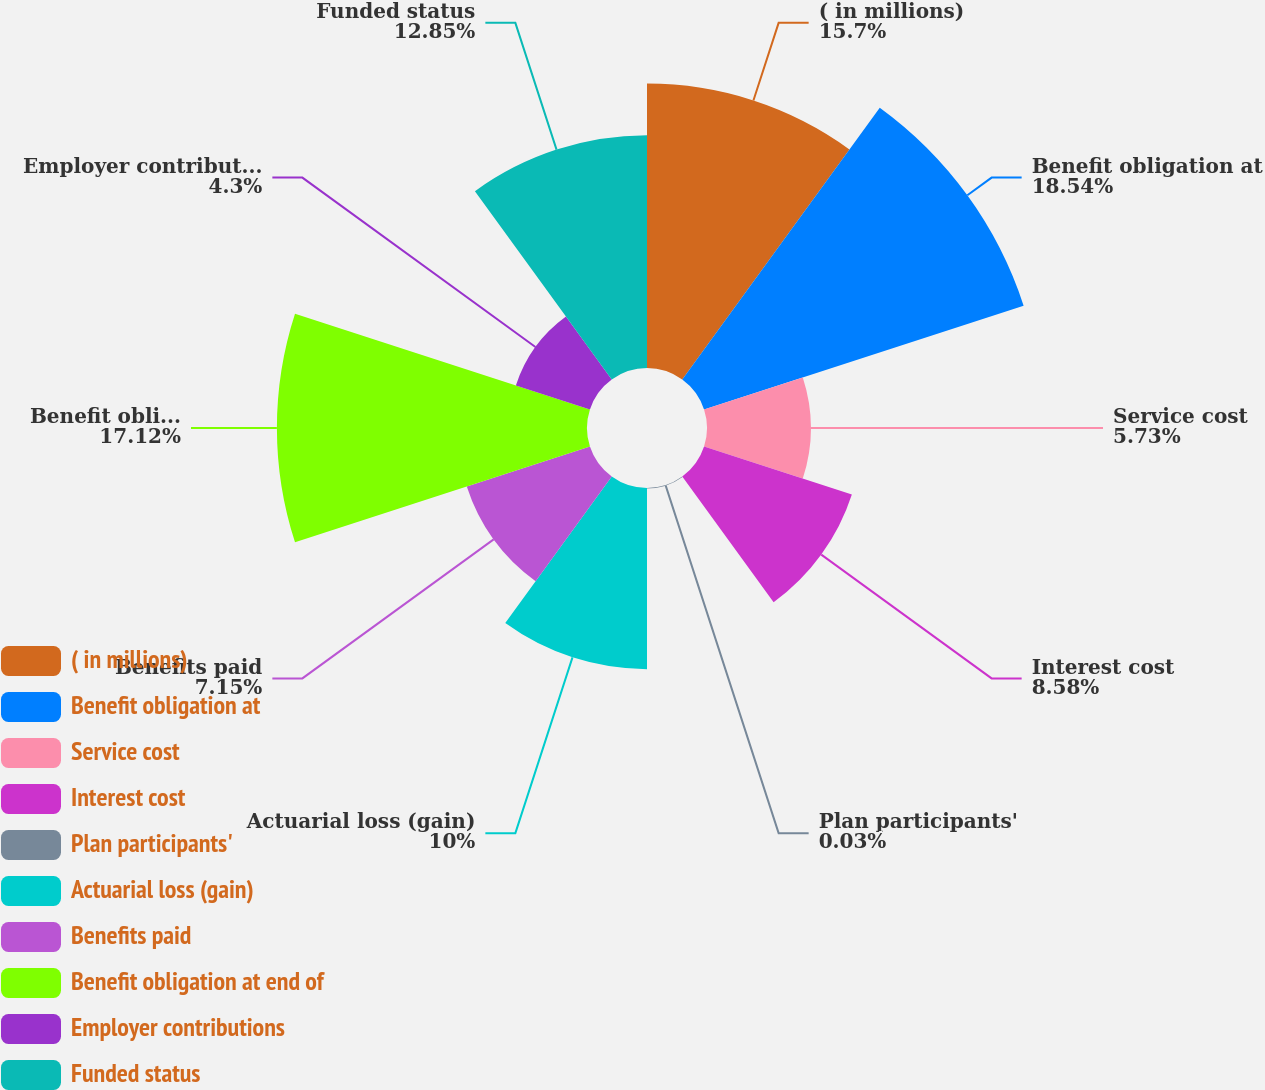Convert chart to OTSL. <chart><loc_0><loc_0><loc_500><loc_500><pie_chart><fcel>( in millions)<fcel>Benefit obligation at<fcel>Service cost<fcel>Interest cost<fcel>Plan participants'<fcel>Actuarial loss (gain)<fcel>Benefits paid<fcel>Benefit obligation at end of<fcel>Employer contributions<fcel>Funded status<nl><fcel>15.7%<fcel>18.55%<fcel>5.73%<fcel>8.58%<fcel>0.03%<fcel>10.0%<fcel>7.15%<fcel>17.12%<fcel>4.3%<fcel>12.85%<nl></chart> 